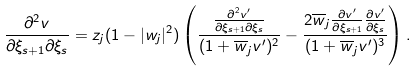<formula> <loc_0><loc_0><loc_500><loc_500>\frac { \partial ^ { 2 } v } { \partial \xi _ { s + 1 } \partial \xi _ { s } } = z _ { j } ( 1 - | w _ { j } | ^ { 2 } ) \left ( \frac { \frac { \partial ^ { 2 } v ^ { \prime } } { \partial \xi _ { s + 1 } \partial \xi _ { s } } } { ( 1 + \overline { w } _ { j } v ^ { \prime } ) ^ { 2 } } - \frac { 2 \overline { w } _ { j } \frac { \partial v ^ { \prime } } { \partial \xi _ { s + 1 } } \frac { \partial v ^ { \prime } } { \partial \xi _ { s } } } { ( 1 + \overline { w } _ { j } v ^ { \prime } ) ^ { 3 } } \right ) .</formula> 